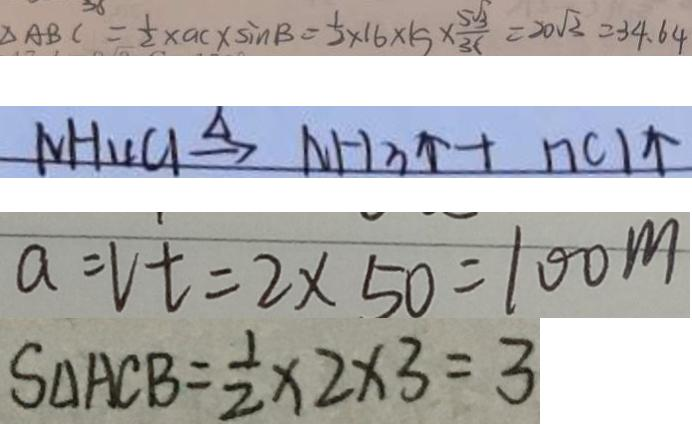<formula> <loc_0><loc_0><loc_500><loc_500>\Delta A B C = \frac { 1 } { 2 } \times a c \times \sin B = \frac { 1 } { 2 } \times 1 6 \times 1 5 \times \frac { 5 \sqrt { 3 } } { 3 6 } = 2 0 \sqrt { 3 } = 3 4 . 6 4 
 N H _ { 4 } C l \xrightarrow { \Delta } N H _ { 3 } \uparrow + n C l \uparrow 
 a = V t = 2 \times 5 0 = 1 0 0 m 
 S _ { \Delta } A C B = \frac { 1 } { 2 } \times 2 \times 3 = 3</formula> 